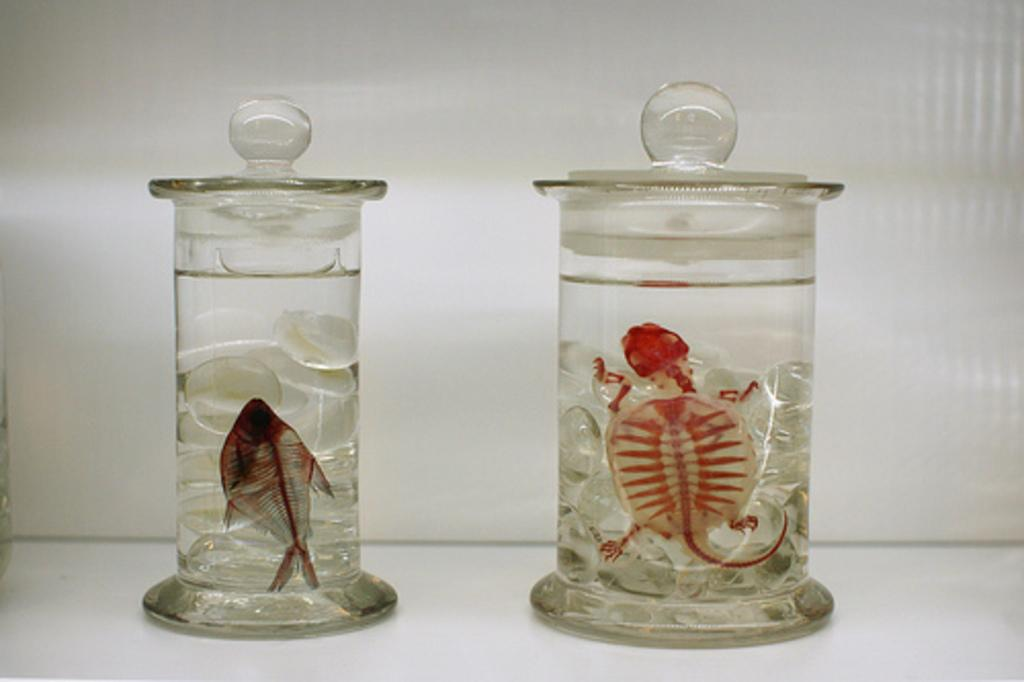How many glass containers are visible in the image? There are two glass containers in the image. What is the color of the surface on which the containers are placed? The containers are on a white surface. What type of animals can be seen inside the containers? There are aquatic animals inside the containers. What type of dress is the judge wearing in the image? There is no judge or dress present in the image; it features two glass containers with aquatic animals inside. 